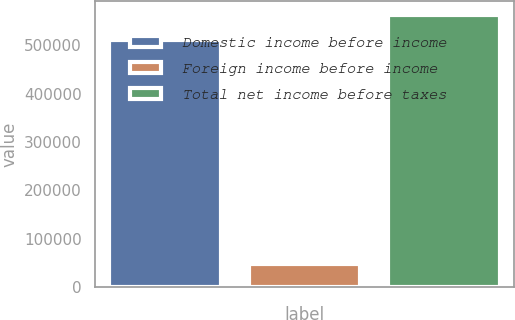Convert chart to OTSL. <chart><loc_0><loc_0><loc_500><loc_500><bar_chart><fcel>Domestic income before income<fcel>Foreign income before income<fcel>Total net income before taxes<nl><fcel>511710<fcel>48523<fcel>562881<nl></chart> 